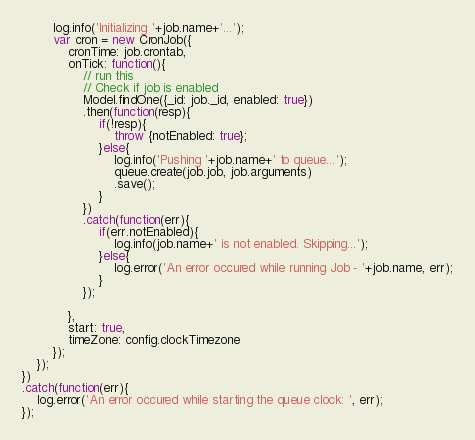<code> <loc_0><loc_0><loc_500><loc_500><_JavaScript_>        log.info('Initializing '+job.name+'...');
        var cron = new CronJob({
            cronTime: job.crontab,
            onTick: function(){
                // run this
                // Check if job is enabled
                Model.findOne({_id: job._id, enabled: true})
                .then(function(resp){
                    if(!resp){
                        throw {notEnabled: true};
                    }else{
                        log.info('Pushing '+job.name+' to queue...');
                        queue.create(job.job, job.arguments)
                        .save();
                    }
                })
                .catch(function(err){
                    if(err.notEnabled){
                        log.info(job.name+' is not enabled. Skipping...');
                    }else{
                        log.error('An error occured while running Job - '+job.name, err);
                    }
                });

            },
            start: true,
            timeZone: config.clockTimezone
        });
    });
})
.catch(function(err){
    log.error('An error occured while starting the queue clock: ', err);
});
</code> 